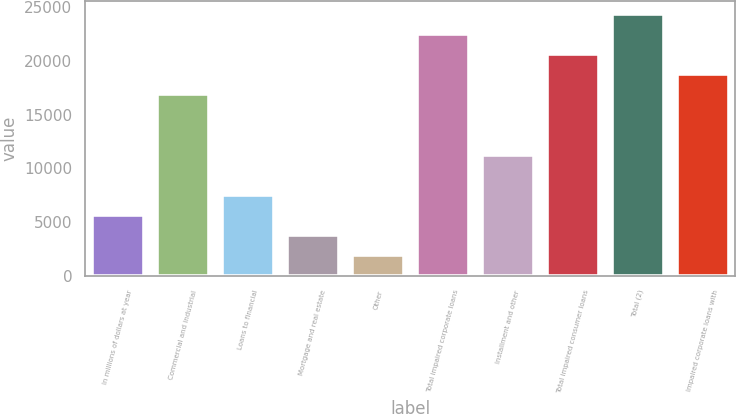Convert chart. <chart><loc_0><loc_0><loc_500><loc_500><bar_chart><fcel>In millions of dollars at year<fcel>Commercial and industrial<fcel>Loans to financial<fcel>Mortgage and real estate<fcel>Other<fcel>Total impaired corporate loans<fcel>Installment and other<fcel>Total impaired consumer loans<fcel>Total (2)<fcel>Impaired corporate loans with<nl><fcel>5657.2<fcel>16873.6<fcel>7526.6<fcel>3787.8<fcel>1918.4<fcel>22481.8<fcel>11265.4<fcel>20612.4<fcel>24351.2<fcel>18743<nl></chart> 